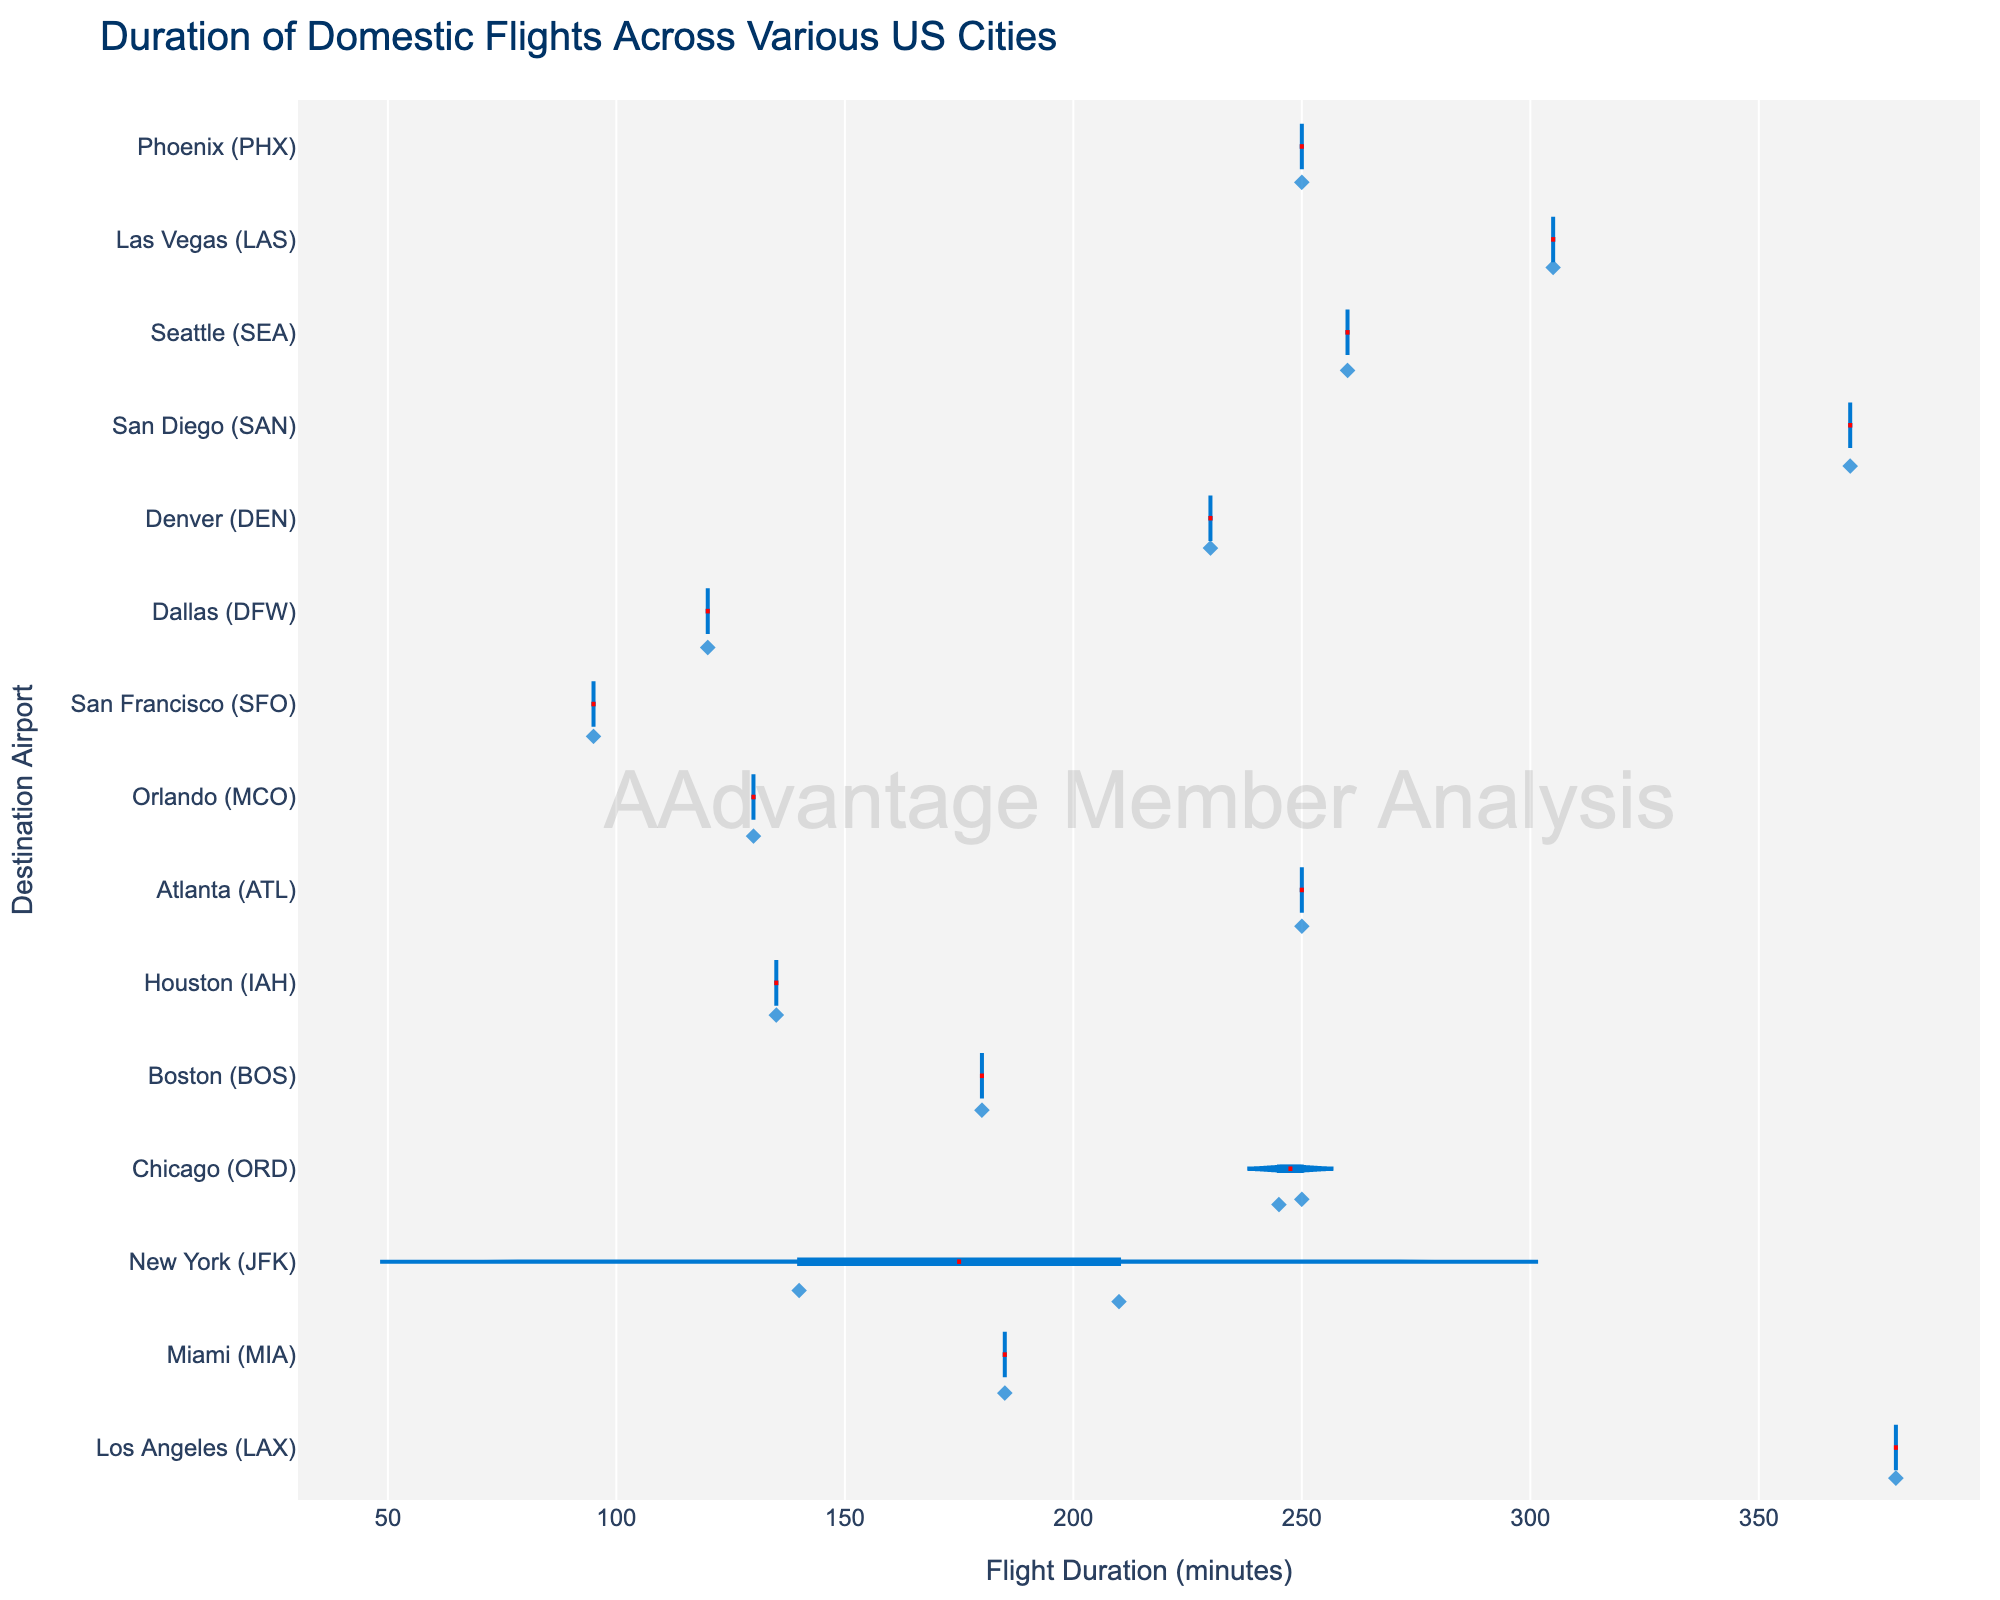What is the title of the chart? The title is displayed at the top of the chart. It is usually in a larger font size and bolded to stand out.
Answer: Duration of Domestic Flights Across Various US Cities What does the color of the traces represent in the chart? All traces are colored with a single color indicating flight details. Each trace's color reflects its duration.
Answer: Blue Which city has the widest range in flight durations? Look at the violin shapes and compare their width. The city with the widest range will have the most spread out violin shape.
Answer: Las Vegas (LAS) What is the median flight duration for flights destined for Phoenix (PHX)? The box in the violin plot represents the interquartile range, and the line inside the box shows the median. Locate the box for Phoenix (PHX) and identify the line's position on the duration axis.
Answer: Approximately 185 minutes Which destination city has the shortest minimum flight duration and what is it? Identify the minimum bounds of the violins and find the shortest one. Look at the scale on the x-axis to determine the duration.
Answer: San Francisco (SFO), 95 minutes Are there any destinations that have outliers in flight durations? Check for points outside the box in the violin plots. Outliers will be marked separately.
Answer: Yes, several destinations (like Charlotte (CLT) and Seattle (SEA)) have outliers Which destination city has the smallest median flight duration? Locate the median lines (inside the boxes) for all cities and compare their durations on the x-axis. The smallest one will be closest to the y-axis origin.
Answer: Washington (DCA) What is the average flight duration for flights destined for Seattle (SEA)? Locate all data points for Seattle (SEA) within the violin plot. Sum all the durations and divide by the number of flights.
Answer: Approximately 255 minutes How does the mean flight duration for Miami (MIA) compare to that of Boston (BOS)? Identify the mean lines in the violin plots for both Miami (MIA) and Boston (BOS) and compare their positions on the duration axis.
Answer: The mean duration is higher for Boston (BOS) Which city has a flight with the maximum duration and what is it? Examine the far-right end of the violin plots to find the maximum duration. Consult the scale on the x-axis to determine the specific value.
Answer: New York (JFK), 380 minutes 